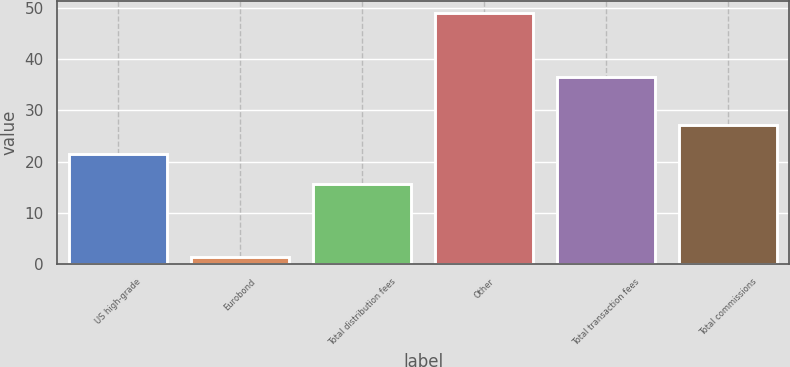<chart> <loc_0><loc_0><loc_500><loc_500><bar_chart><fcel>US high-grade<fcel>Eurobond<fcel>Total distribution fees<fcel>Other<fcel>Total transaction fees<fcel>Total commissions<nl><fcel>21.5<fcel>1.3<fcel>15.7<fcel>49<fcel>36.5<fcel>27.1<nl></chart> 